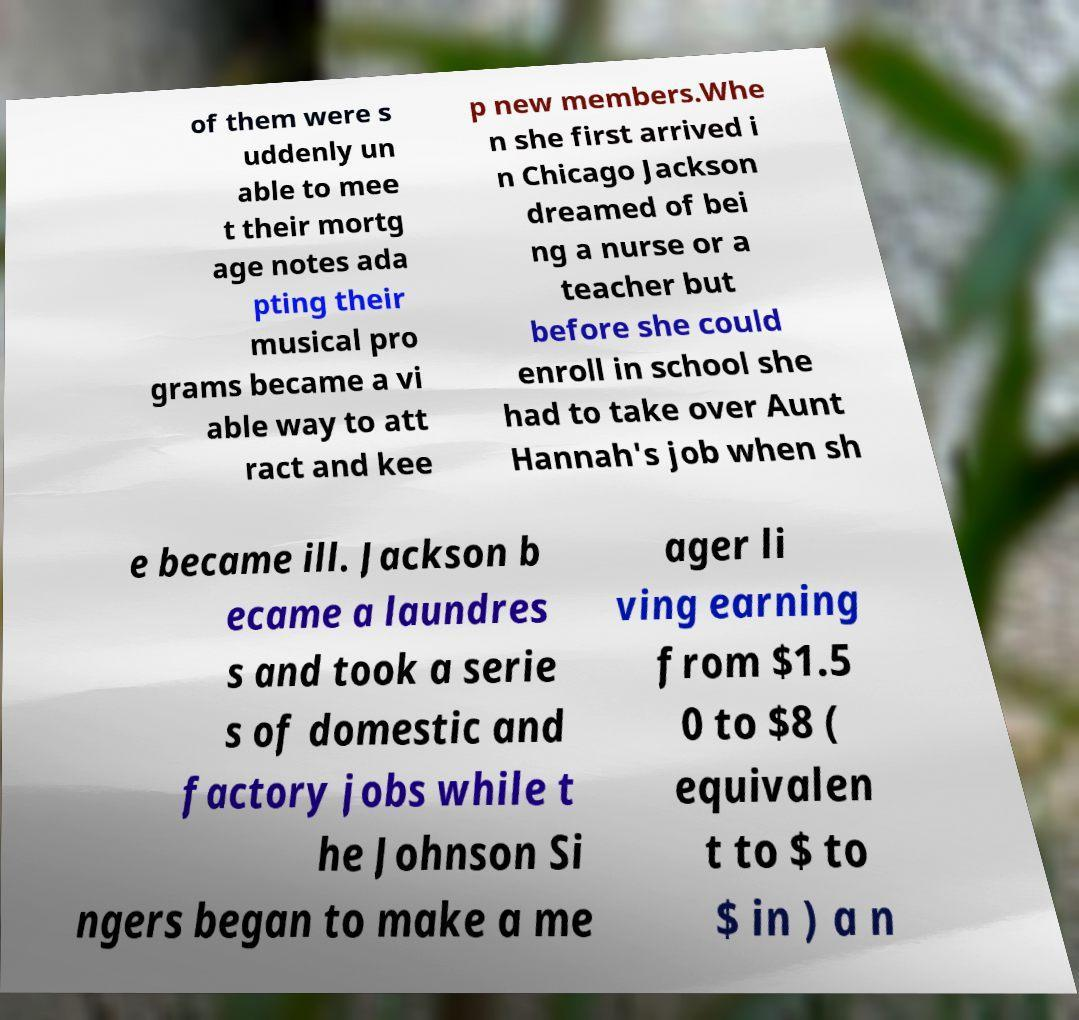For documentation purposes, I need the text within this image transcribed. Could you provide that? of them were s uddenly un able to mee t their mortg age notes ada pting their musical pro grams became a vi able way to att ract and kee p new members.Whe n she first arrived i n Chicago Jackson dreamed of bei ng a nurse or a teacher but before she could enroll in school she had to take over Aunt Hannah's job when sh e became ill. Jackson b ecame a laundres s and took a serie s of domestic and factory jobs while t he Johnson Si ngers began to make a me ager li ving earning from $1.5 0 to $8 ( equivalen t to $ to $ in ) a n 